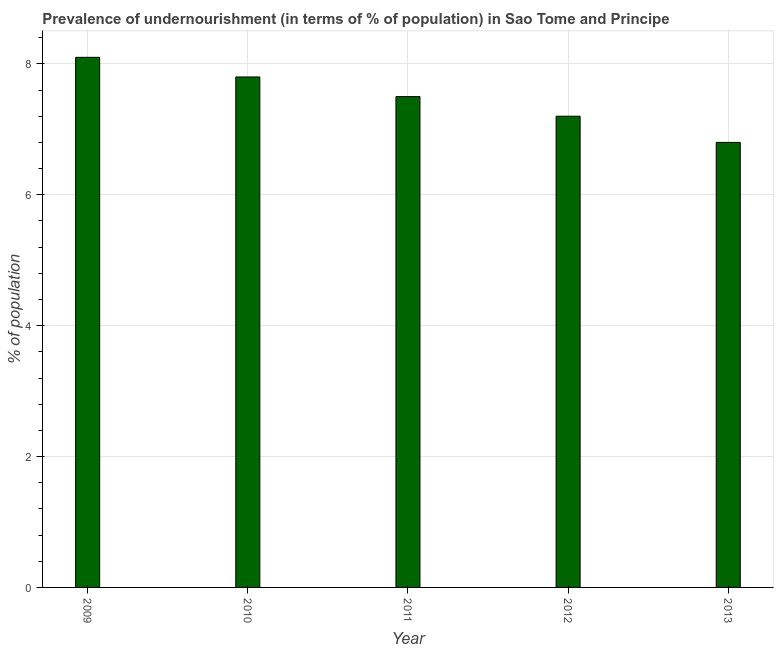Does the graph contain grids?
Your answer should be very brief. Yes. What is the title of the graph?
Keep it short and to the point. Prevalence of undernourishment (in terms of % of population) in Sao Tome and Principe. What is the label or title of the X-axis?
Your answer should be compact. Year. What is the label or title of the Y-axis?
Keep it short and to the point. % of population. In which year was the percentage of undernourished population maximum?
Keep it short and to the point. 2009. What is the sum of the percentage of undernourished population?
Your response must be concise. 37.4. What is the difference between the percentage of undernourished population in 2011 and 2013?
Provide a short and direct response. 0.7. What is the average percentage of undernourished population per year?
Provide a succinct answer. 7.48. Do a majority of the years between 2009 and 2011 (inclusive) have percentage of undernourished population greater than 0.8 %?
Provide a succinct answer. Yes. Is the percentage of undernourished population in 2011 less than that in 2012?
Give a very brief answer. No. Is the sum of the percentage of undernourished population in 2009 and 2011 greater than the maximum percentage of undernourished population across all years?
Your response must be concise. Yes. What is the difference between two consecutive major ticks on the Y-axis?
Your response must be concise. 2. What is the % of population in 2009?
Give a very brief answer. 8.1. What is the % of population in 2012?
Give a very brief answer. 7.2. What is the % of population of 2013?
Make the answer very short. 6.8. What is the difference between the % of population in 2009 and 2011?
Ensure brevity in your answer.  0.6. What is the difference between the % of population in 2009 and 2012?
Provide a short and direct response. 0.9. What is the difference between the % of population in 2010 and 2011?
Ensure brevity in your answer.  0.3. What is the difference between the % of population in 2010 and 2012?
Provide a short and direct response. 0.6. What is the difference between the % of population in 2010 and 2013?
Ensure brevity in your answer.  1. What is the difference between the % of population in 2011 and 2012?
Your response must be concise. 0.3. What is the ratio of the % of population in 2009 to that in 2010?
Keep it short and to the point. 1.04. What is the ratio of the % of population in 2009 to that in 2011?
Provide a succinct answer. 1.08. What is the ratio of the % of population in 2009 to that in 2013?
Your answer should be very brief. 1.19. What is the ratio of the % of population in 2010 to that in 2011?
Your answer should be compact. 1.04. What is the ratio of the % of population in 2010 to that in 2012?
Your answer should be very brief. 1.08. What is the ratio of the % of population in 2010 to that in 2013?
Offer a terse response. 1.15. What is the ratio of the % of population in 2011 to that in 2012?
Your answer should be very brief. 1.04. What is the ratio of the % of population in 2011 to that in 2013?
Provide a short and direct response. 1.1. What is the ratio of the % of population in 2012 to that in 2013?
Keep it short and to the point. 1.06. 